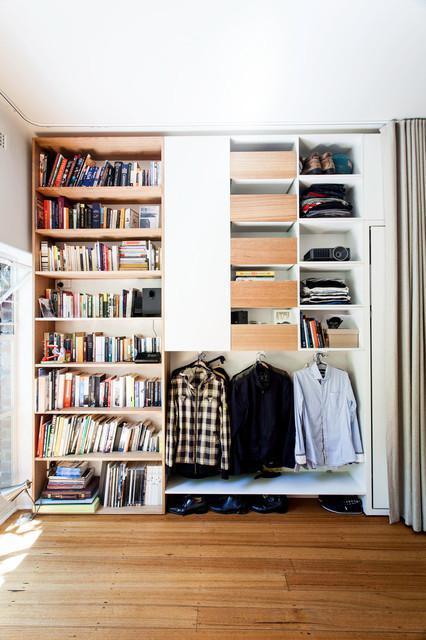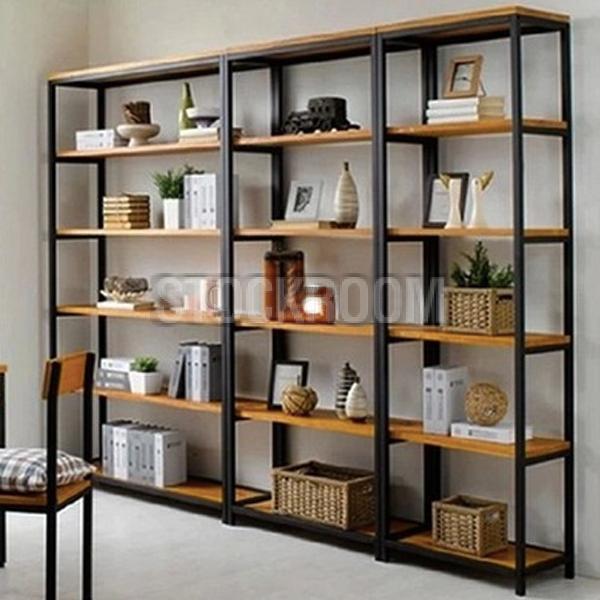The first image is the image on the left, the second image is the image on the right. For the images shown, is this caption "In one image, a wall bookshelf unit with at least six shelves has at least one piece of framed artwork mounted to the front of the shelf, obscuring some of the contents." true? Answer yes or no. No. The first image is the image on the left, the second image is the image on the right. Considering the images on both sides, is "The right image shows a ladder leaned up against the front of a stocked bookshelf." valid? Answer yes or no. No. 